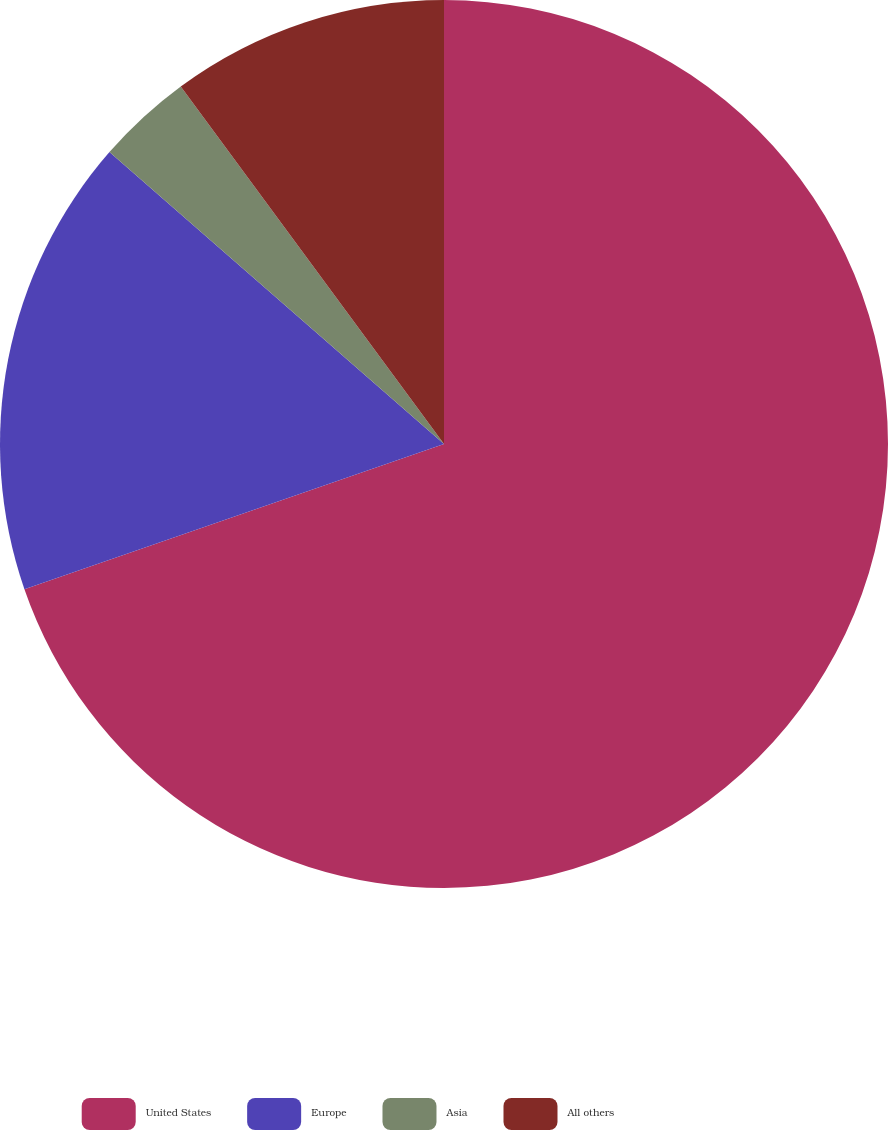Convert chart. <chart><loc_0><loc_0><loc_500><loc_500><pie_chart><fcel>United States<fcel>Europe<fcel>Asia<fcel>All others<nl><fcel>69.69%<fcel>16.72%<fcel>3.48%<fcel>10.1%<nl></chart> 